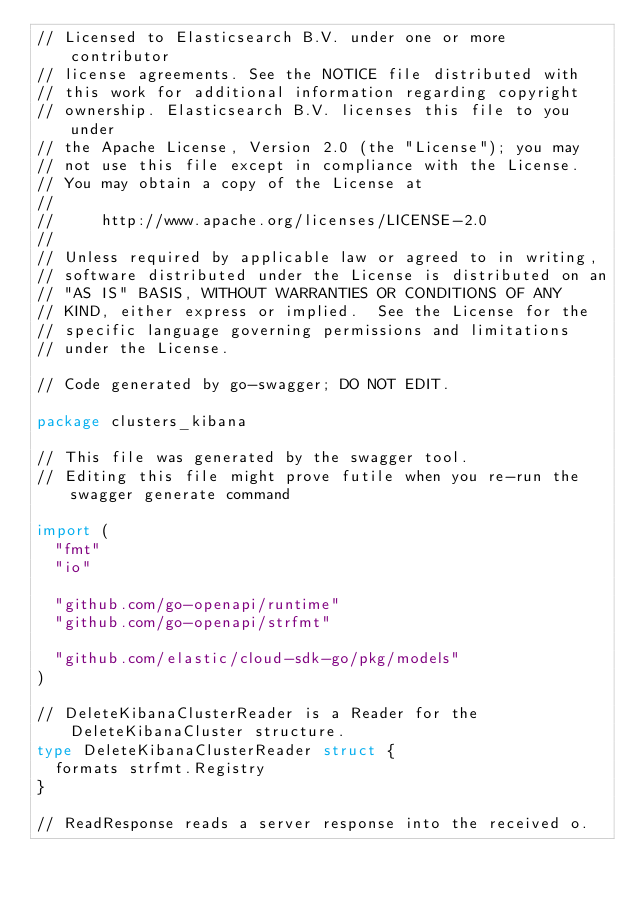Convert code to text. <code><loc_0><loc_0><loc_500><loc_500><_Go_>// Licensed to Elasticsearch B.V. under one or more contributor
// license agreements. See the NOTICE file distributed with
// this work for additional information regarding copyright
// ownership. Elasticsearch B.V. licenses this file to you under
// the Apache License, Version 2.0 (the "License"); you may
// not use this file except in compliance with the License.
// You may obtain a copy of the License at
//
//     http://www.apache.org/licenses/LICENSE-2.0
//
// Unless required by applicable law or agreed to in writing,
// software distributed under the License is distributed on an
// "AS IS" BASIS, WITHOUT WARRANTIES OR CONDITIONS OF ANY
// KIND, either express or implied.  See the License for the
// specific language governing permissions and limitations
// under the License.

// Code generated by go-swagger; DO NOT EDIT.

package clusters_kibana

// This file was generated by the swagger tool.
// Editing this file might prove futile when you re-run the swagger generate command

import (
	"fmt"
	"io"

	"github.com/go-openapi/runtime"
	"github.com/go-openapi/strfmt"

	"github.com/elastic/cloud-sdk-go/pkg/models"
)

// DeleteKibanaClusterReader is a Reader for the DeleteKibanaCluster structure.
type DeleteKibanaClusterReader struct {
	formats strfmt.Registry
}

// ReadResponse reads a server response into the received o.</code> 